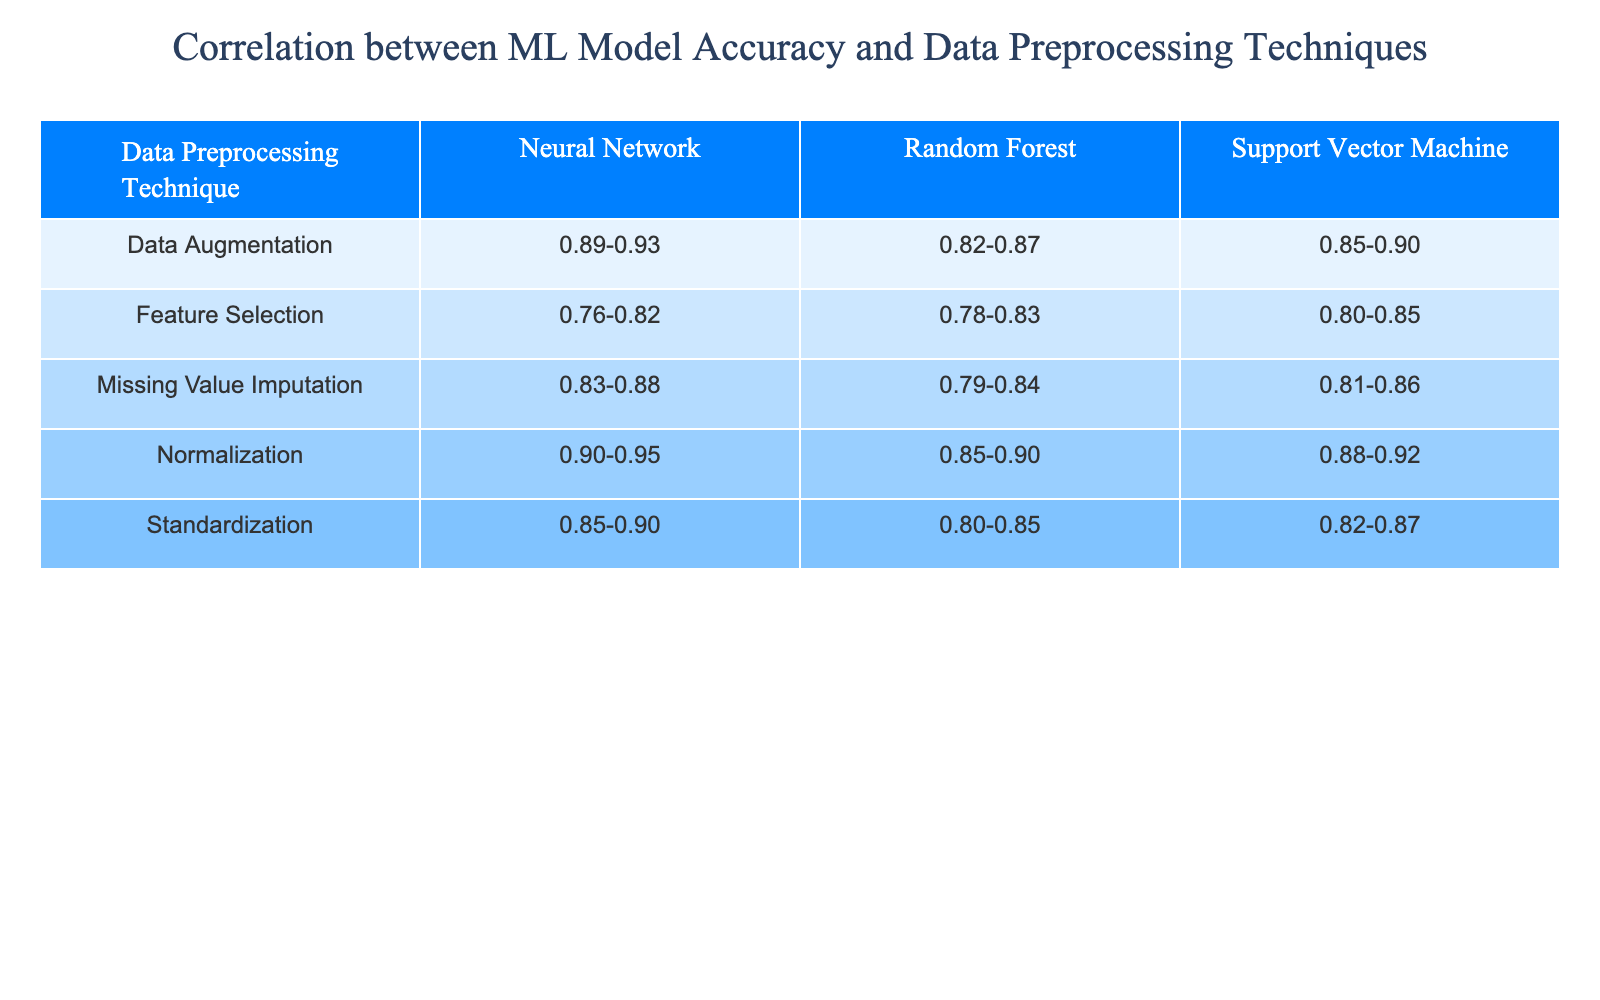What is the accuracy range for Random Forest when using Normalization? From the table, we can locate the row for "Normalization" under the column for "Random Forest." The accuracy range displayed is "0.85-0.90."
Answer: 0.85-0.90 Which data preprocessing technique yields the highest accuracy for Neural Networks? Analyzing the rows for Neural Networks, we find that the accuracy ranges are "0.90-0.95" for Normalization, "0.85-0.90" for Standardization, "0.76-0.82" for Feature Selection, "0.89-0.93" for Data Augmentation, and "0.83-0.88" for Missing Value Imputation. The highest accuracy range is "0.90-0.95" from Normalization.
Answer: Normalization Is it true that Standardization provides a higher accuracy range for Support Vector Machines than Feature Selection? By comparing the accuracy ranges from the table, Standardization for Support Vector Machines has an accuracy range of "0.82-0.87," while Feature Selection has "0.80-0.85." Since "0.82-0.87" is greater than "0.80-0.85," the statement is true.
Answer: Yes What is the average accuracy range for Random Forest across all preprocessing techniques? The accuracy ranges for Random Forest are "0.85-0.90" (Normalization), "0.80-0.85" (Standardization), "0.78-0.83" (Feature Selection), "0.82-0.87" (Data Augmentation), and "0.79-0.84" (Missing Value Imputation). To find the average, we convert the ranges to numerical values: average of (0.85, 0.90), (0.80, 0.85), (0.78, 0.83), (0.82, 0.87), (0.79, 0.84). The midpoints are approximately 0.875, 0.825, 0.805, 0.845, and 0.815, giving an overall average of about 0.821.
Answer: Approximately 0.821 Which preprocessing technique shows the least improvement in accuracy for Neural Networks compared to Random Forest? Looking at the accuracy ranges: for Random Forest, we have "0.85-0.90" (Normalization) and "0.90-0.95" (Neural Network) - a difference of about 0.05. For Standardization, "0.80-0.85" (RF) to "0.85-0.90" (NN) is a difference of 0.05. For Feature Selection, "0.78-0.83" (RF) to "0.76-0.82" (NN) is actually a decrease. Data Augmentation goes from "0.82-0.87" (RF) to "0.89-0.93" (NN) at an increase of 0.07. Missing Value Imputation goes from "0.79-0.84" to "0.83-0.88," showing a smaller increase of 0.04. The least improvement is thus with Feature Selection, showing a decrease.
Answer: Feature Selection 